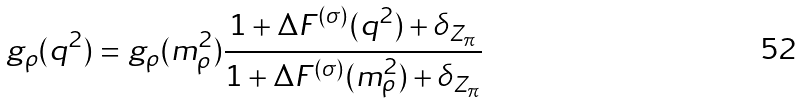Convert formula to latex. <formula><loc_0><loc_0><loc_500><loc_500>g _ { \rho } ( q ^ { 2 } ) = g _ { \rho } ( m _ { \rho } ^ { 2 } ) \frac { 1 + \Delta F ^ { ( \sigma ) } ( q ^ { 2 } ) + \delta _ { Z _ { \pi } } } { 1 + \Delta F ^ { ( \sigma ) } ( m _ { \rho } ^ { 2 } ) + \delta _ { Z _ { \pi } } }</formula> 